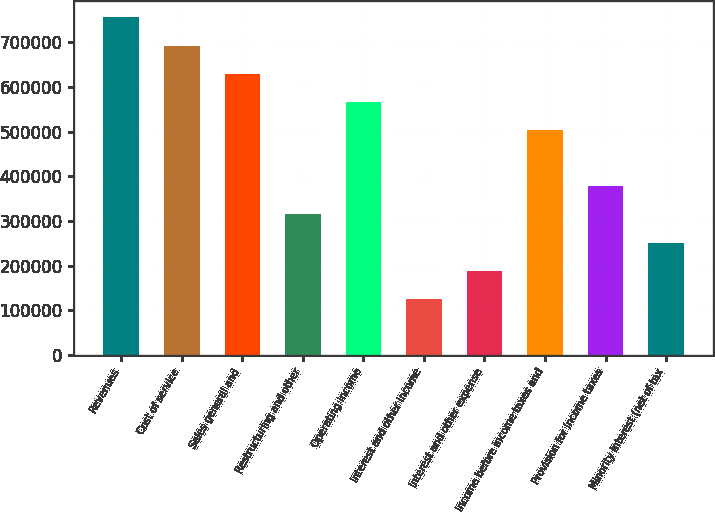<chart> <loc_0><loc_0><loc_500><loc_500><bar_chart><fcel>Revenues<fcel>Cost of service<fcel>Sales general and<fcel>Restructuring and other<fcel>Operating income<fcel>Interest and other income<fcel>Interest and other expense<fcel>Income before income taxes and<fcel>Provision for income taxes<fcel>Minority interest (net of tax<nl><fcel>755184<fcel>692252<fcel>629320<fcel>314661<fcel>566388<fcel>125865<fcel>188797<fcel>503456<fcel>377593<fcel>251729<nl></chart> 